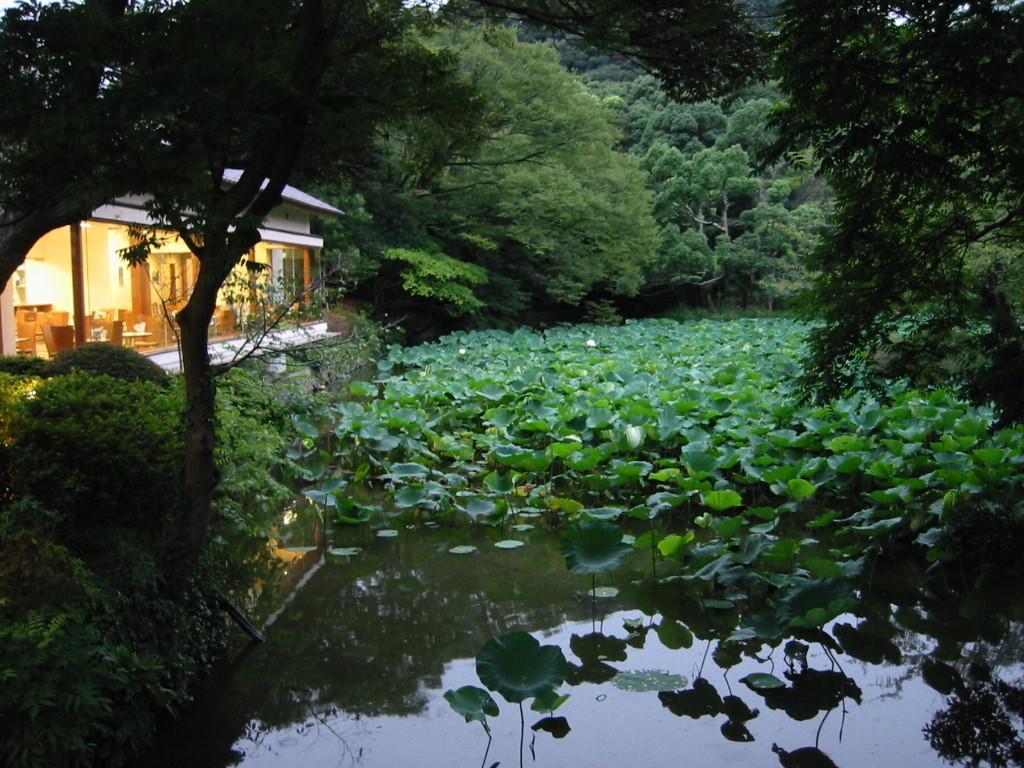How would you summarize this image in a sentence or two? In this image plants are in water. Left side there is a house having a glass wall. From the glass wall few chairs and tables are visible. Few lights are attached to the wall. Background there are trees. Left bottom there are plants on the land. 